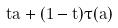Convert formula to latex. <formula><loc_0><loc_0><loc_500><loc_500>t \tilde { a } + ( 1 - t ) \tau ( \tilde { a } )</formula> 